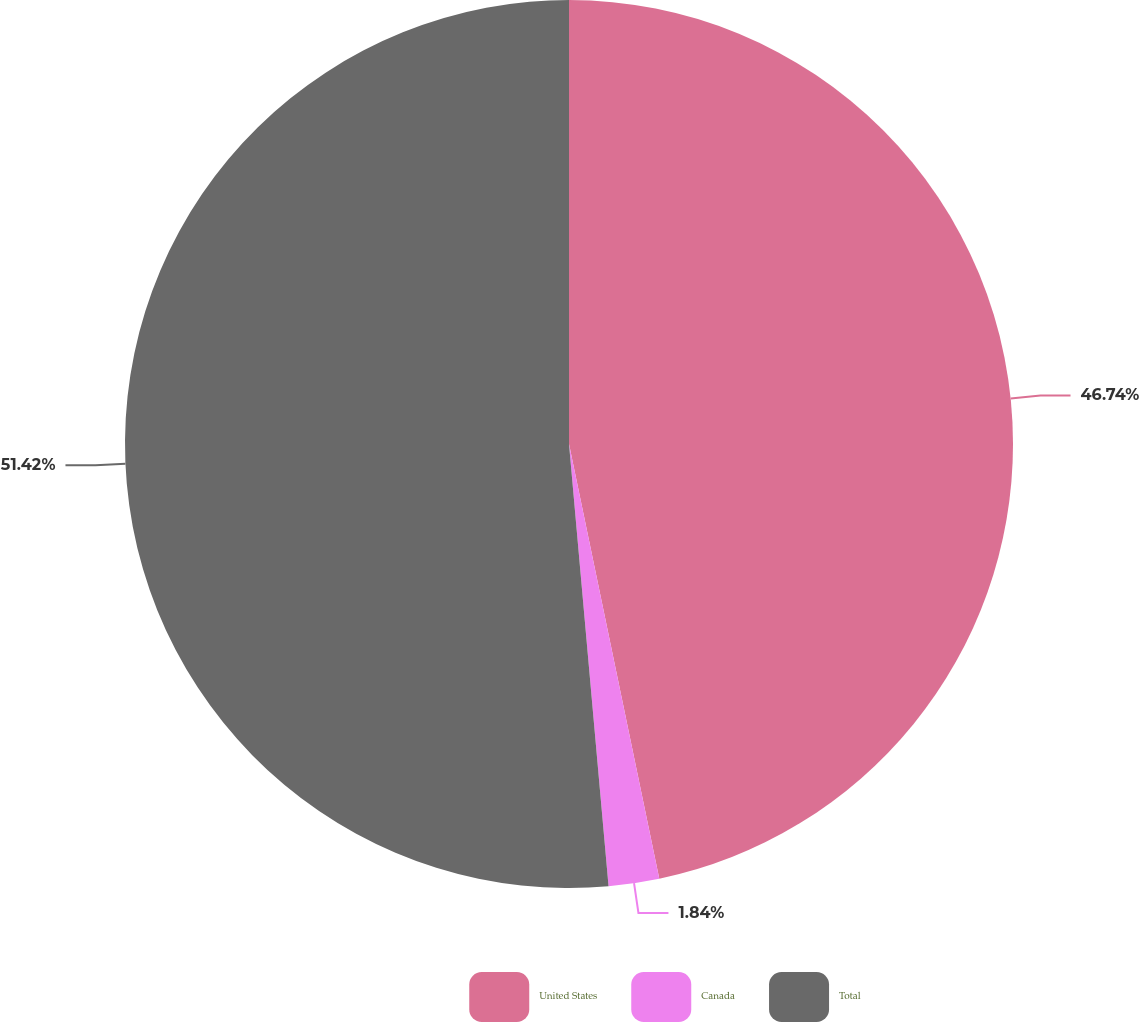Convert chart to OTSL. <chart><loc_0><loc_0><loc_500><loc_500><pie_chart><fcel>United States<fcel>Canada<fcel>Total<nl><fcel>46.74%<fcel>1.84%<fcel>51.42%<nl></chart> 